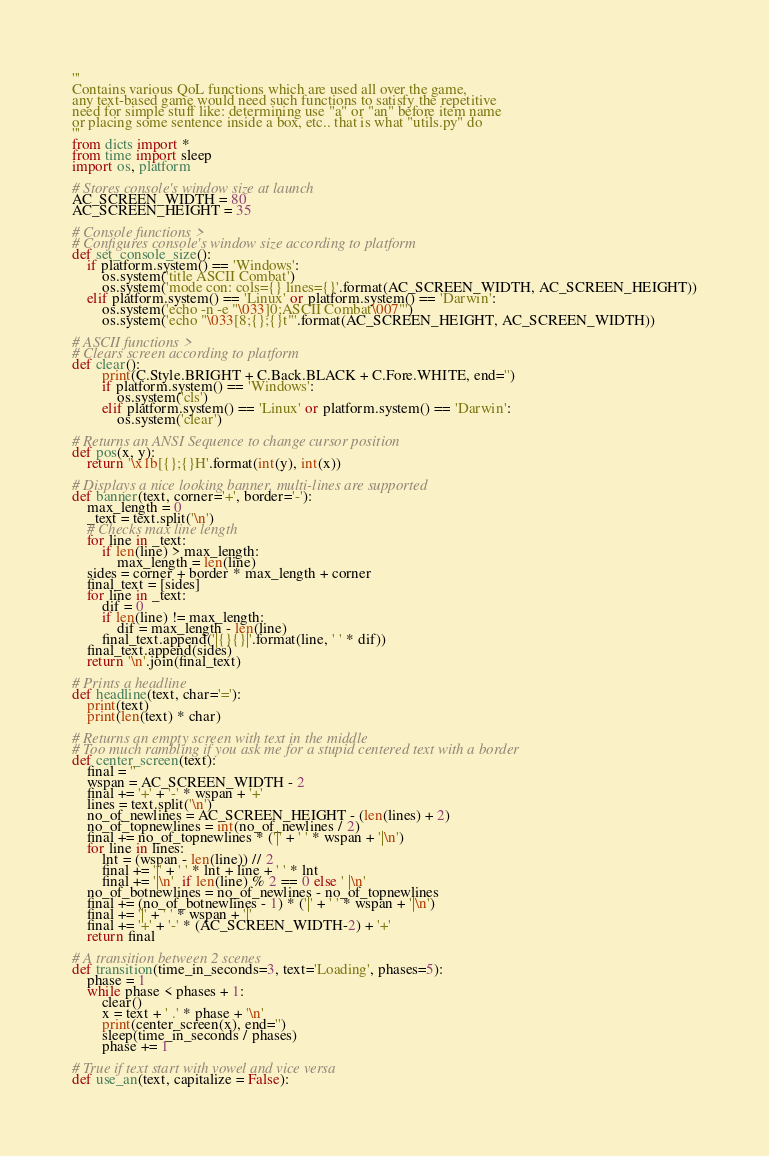Convert code to text. <code><loc_0><loc_0><loc_500><loc_500><_Python_>'''
Contains various QoL functions which are used all over the game,
any text-based game would need such functions to satisfy the repetitive
need for simple stuff like: determining use "a" or "an" before item name
or placing some sentence inside a box, etc.. that is what "utils.py" do
'''
from dicts import *
from time import sleep
import os, platform

# Stores console's window size at launch
AC_SCREEN_WIDTH = 80
AC_SCREEN_HEIGHT = 35

# Console functions >
# Configures console's window size according to platform
def set_console_size():
    if platform.system() == 'Windows':
        os.system('title ASCII Combat')
        os.system('mode con: cols={} lines={}'.format(AC_SCREEN_WIDTH, AC_SCREEN_HEIGHT))
    elif platform.system() == 'Linux' or platform.system() == 'Darwin':
        os.system('echo -n -e "\033]0;ASCII Combat\007"')
        os.system('echo "\033[8;{};{}t"'.format(AC_SCREEN_HEIGHT, AC_SCREEN_WIDTH))

# ASCII functions >
# Clears screen according to platform
def clear():
        print(C.Style.BRIGHT + C.Back.BLACK + C.Fore.WHITE, end='')
        if platform.system() == 'Windows':
            os.system('cls')
        elif platform.system() == 'Linux' or platform.system() == 'Darwin':
            os.system('clear')

# Returns an ANSI Sequence to change cursor position
def pos(x, y):
    return '\x1b[{};{}H'.format(int(y), int(x))

# Displays a nice looking banner, multi-lines are supported
def banner(text, corner='+', border='-'):
    max_length = 0
    _text = text.split('\n')
    # Checks max line length
    for line in _text:
        if len(line) > max_length:
            max_length = len(line)
    sides = corner + border * max_length + corner
    final_text = [sides]
    for line in _text:
        dif = 0
        if len(line) != max_length:
            dif = max_length - len(line)
        final_text.append('|{}{}|'.format(line, ' ' * dif))
    final_text.append(sides)
    return '\n'.join(final_text)

# Prints a headline
def headline(text, char='='):
    print(text)
    print(len(text) * char)

# Returns an empty screen with text in the middle
# Too much rambling if you ask me for a stupid centered text with a border
def center_screen(text):
    final = ''
    wspan = AC_SCREEN_WIDTH - 2
    final += '+' + '-' * wspan + '+'
    lines = text.split('\n')
    no_of_newlines = AC_SCREEN_HEIGHT - (len(lines) + 2)
    no_of_topnewlines = int(no_of_newlines / 2)
    final += no_of_topnewlines * ('|' + ' ' * wspan + '|\n')
    for line in lines:
        lnt = (wspan - len(line)) // 2
        final += '|' + ' ' * lnt + line + ' ' * lnt
        final += '|\n'  if len(line) % 2 == 0 else ' |\n'
    no_of_botnewlines = no_of_newlines - no_of_topnewlines
    final += (no_of_botnewlines - 1) * ('|' + ' ' * wspan + '|\n')
    final += '|' + ' ' * wspan + '|'
    final += '+' + '-' * (AC_SCREEN_WIDTH-2) + '+'
    return final

# A transition between 2 scenes
def transition(time_in_seconds=3, text='Loading', phases=5):
    phase = 1
    while phase < phases + 1:
        clear()
        x = text + ' .' * phase + '\n'
        print(center_screen(x), end='')
        sleep(time_in_seconds / phases)
        phase += 1

# True if text start with vowel and vice versa
def use_an(text, capitalize = False):</code> 